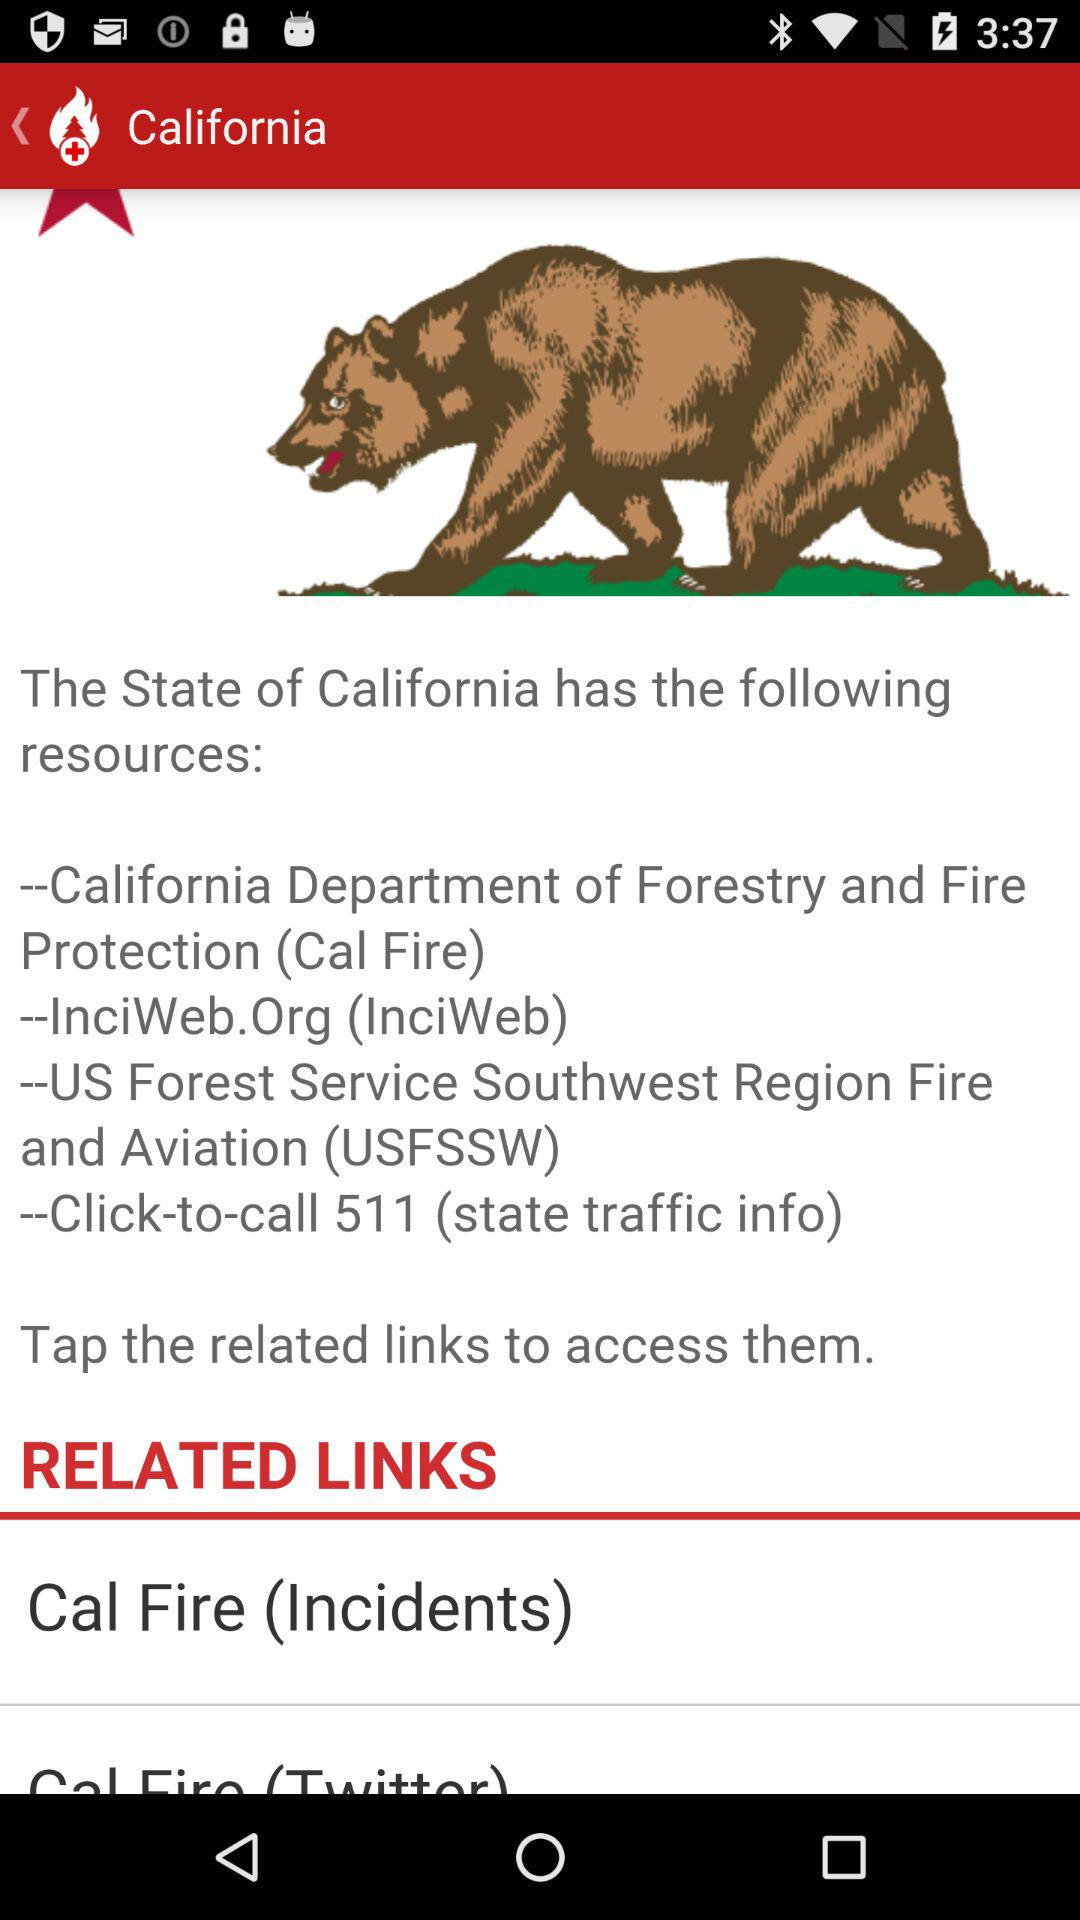What is the location? The location is California. 